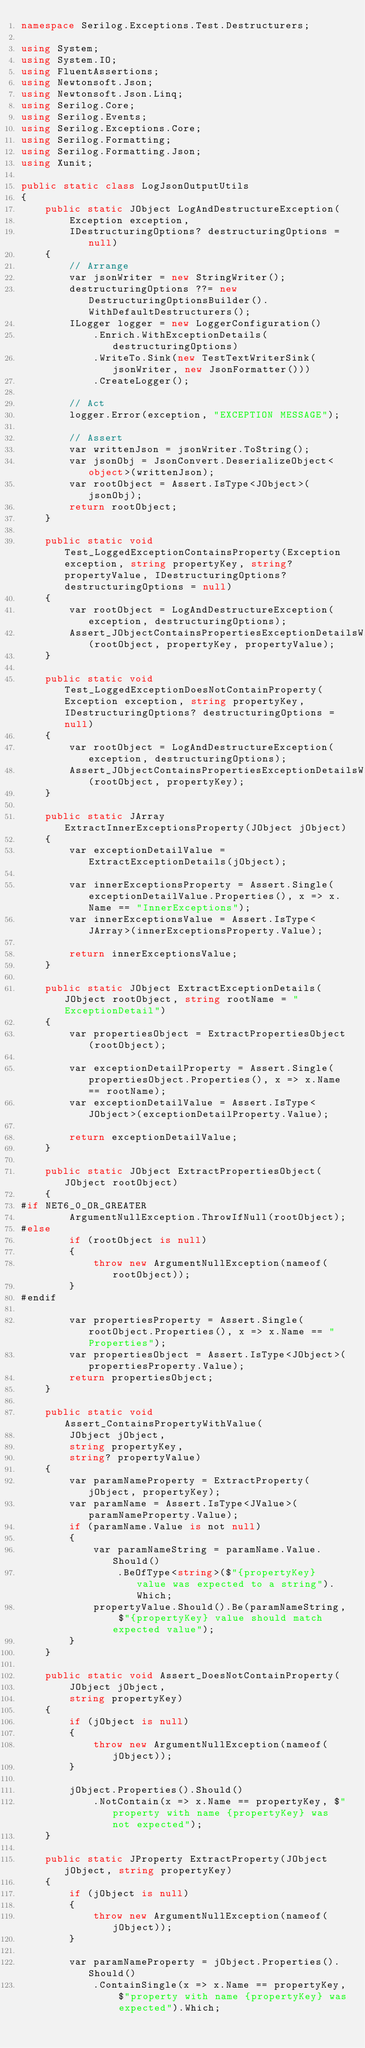<code> <loc_0><loc_0><loc_500><loc_500><_C#_>namespace Serilog.Exceptions.Test.Destructurers;

using System;
using System.IO;
using FluentAssertions;
using Newtonsoft.Json;
using Newtonsoft.Json.Linq;
using Serilog.Core;
using Serilog.Events;
using Serilog.Exceptions.Core;
using Serilog.Formatting;
using Serilog.Formatting.Json;
using Xunit;

public static class LogJsonOutputUtils
{
    public static JObject LogAndDestructureException(
        Exception exception,
        IDestructuringOptions? destructuringOptions = null)
    {
        // Arrange
        var jsonWriter = new StringWriter();
        destructuringOptions ??= new DestructuringOptionsBuilder().WithDefaultDestructurers();
        ILogger logger = new LoggerConfiguration()
            .Enrich.WithExceptionDetails(destructuringOptions)
            .WriteTo.Sink(new TestTextWriterSink(jsonWriter, new JsonFormatter()))
            .CreateLogger();

        // Act
        logger.Error(exception, "EXCEPTION MESSAGE");

        // Assert
        var writtenJson = jsonWriter.ToString();
        var jsonObj = JsonConvert.DeserializeObject<object>(writtenJson);
        var rootObject = Assert.IsType<JObject>(jsonObj);
        return rootObject;
    }

    public static void Test_LoggedExceptionContainsProperty(Exception exception, string propertyKey, string? propertyValue, IDestructuringOptions? destructuringOptions = null)
    {
        var rootObject = LogAndDestructureException(exception, destructuringOptions);
        Assert_JObjectContainsPropertiesExceptionDetailsWithProperty(rootObject, propertyKey, propertyValue);
    }

    public static void Test_LoggedExceptionDoesNotContainProperty(Exception exception, string propertyKey, IDestructuringOptions? destructuringOptions = null)
    {
        var rootObject = LogAndDestructureException(exception, destructuringOptions);
        Assert_JObjectContainsPropertiesExceptionDetailsWithoutProperty(rootObject, propertyKey);
    }

    public static JArray ExtractInnerExceptionsProperty(JObject jObject)
    {
        var exceptionDetailValue = ExtractExceptionDetails(jObject);

        var innerExceptionsProperty = Assert.Single(exceptionDetailValue.Properties(), x => x.Name == "InnerExceptions");
        var innerExceptionsValue = Assert.IsType<JArray>(innerExceptionsProperty.Value);

        return innerExceptionsValue;
    }

    public static JObject ExtractExceptionDetails(JObject rootObject, string rootName = "ExceptionDetail")
    {
        var propertiesObject = ExtractPropertiesObject(rootObject);

        var exceptionDetailProperty = Assert.Single(propertiesObject.Properties(), x => x.Name == rootName);
        var exceptionDetailValue = Assert.IsType<JObject>(exceptionDetailProperty.Value);

        return exceptionDetailValue;
    }

    public static JObject ExtractPropertiesObject(JObject rootObject)
    {
#if NET6_0_OR_GREATER
        ArgumentNullException.ThrowIfNull(rootObject);
#else
        if (rootObject is null)
        {
            throw new ArgumentNullException(nameof(rootObject));
        }
#endif

        var propertiesProperty = Assert.Single(rootObject.Properties(), x => x.Name == "Properties");
        var propertiesObject = Assert.IsType<JObject>(propertiesProperty.Value);
        return propertiesObject;
    }

    public static void Assert_ContainsPropertyWithValue(
        JObject jObject,
        string propertyKey,
        string? propertyValue)
    {
        var paramNameProperty = ExtractProperty(jObject, propertyKey);
        var paramName = Assert.IsType<JValue>(paramNameProperty.Value);
        if (paramName.Value is not null)
        {
            var paramNameString = paramName.Value.Should()
                .BeOfType<string>($"{propertyKey} value was expected to a string").Which;
            propertyValue.Should().Be(paramNameString, $"{propertyKey} value should match expected value");
        }
    }

    public static void Assert_DoesNotContainProperty(
        JObject jObject,
        string propertyKey)
    {
        if (jObject is null)
        {
            throw new ArgumentNullException(nameof(jObject));
        }

        jObject.Properties().Should()
            .NotContain(x => x.Name == propertyKey, $"property with name {propertyKey} was not expected");
    }

    public static JProperty ExtractProperty(JObject jObject, string propertyKey)
    {
        if (jObject is null)
        {
            throw new ArgumentNullException(nameof(jObject));
        }

        var paramNameProperty = jObject.Properties().Should()
            .ContainSingle(x => x.Name == propertyKey, $"property with name {propertyKey} was expected").Which;</code> 